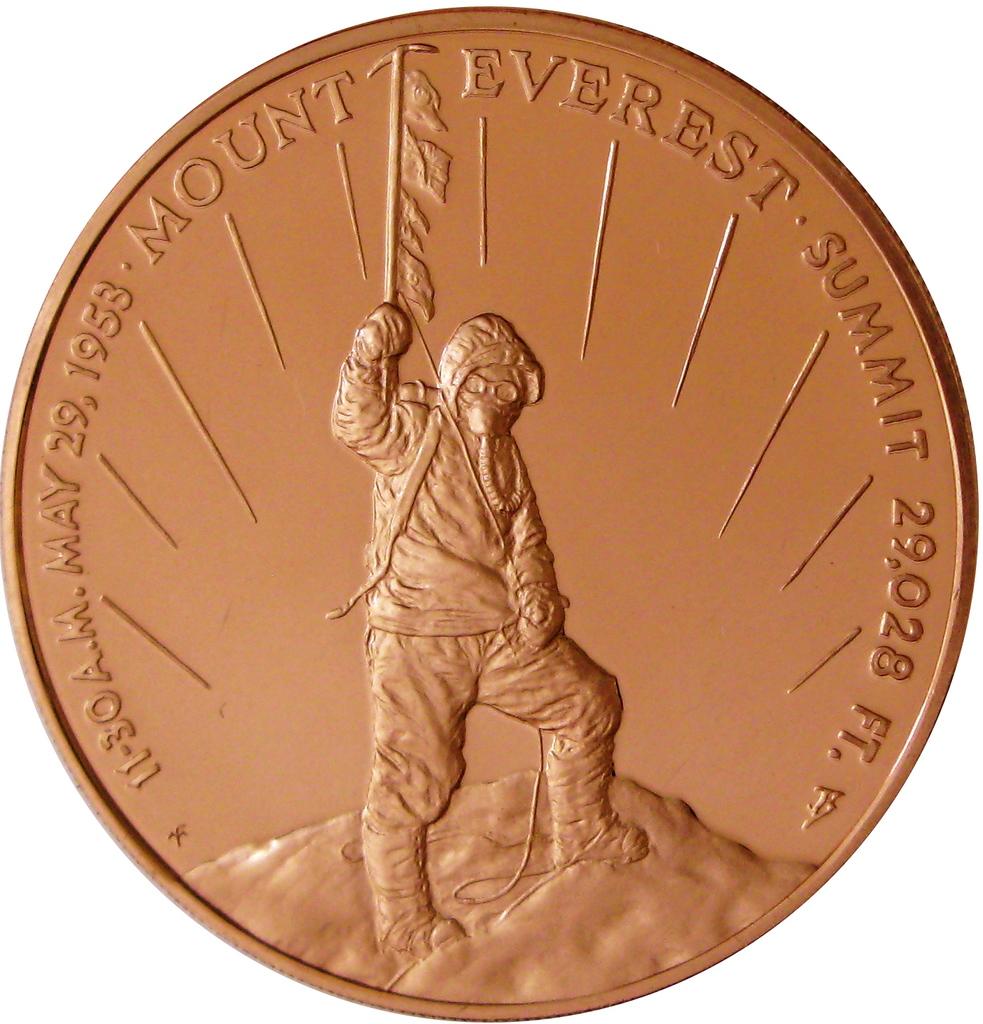How high is mount everest?
Keep it short and to the point. 29,028 feet. 